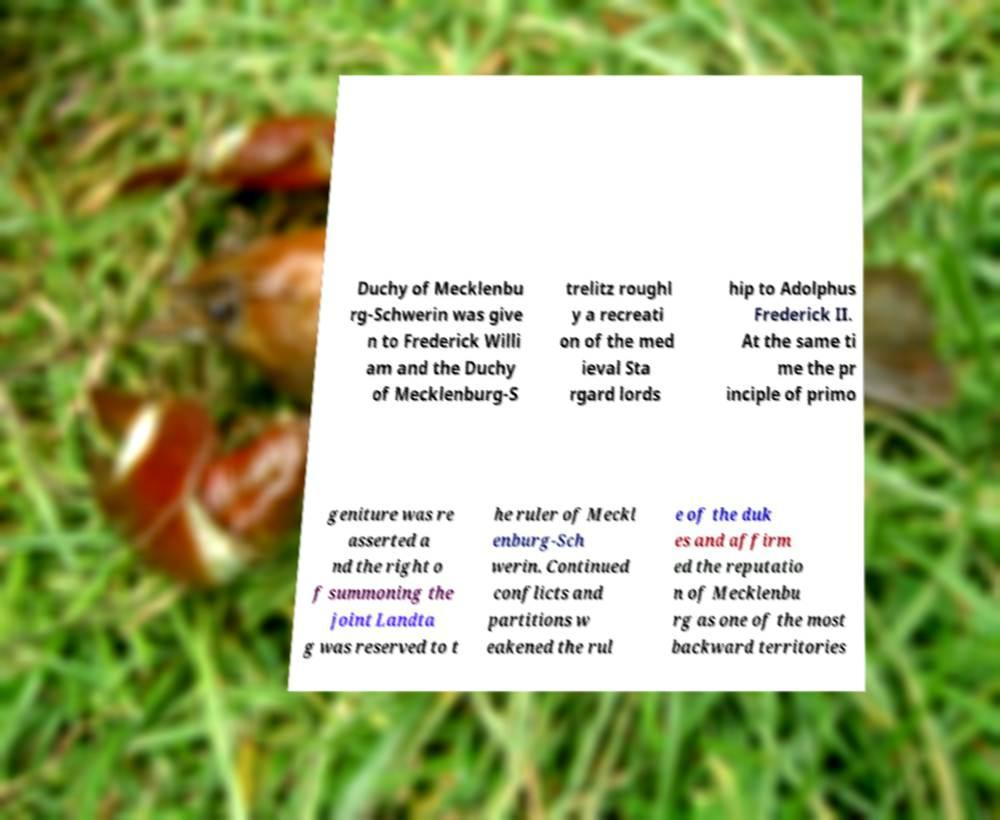Can you read and provide the text displayed in the image?This photo seems to have some interesting text. Can you extract and type it out for me? Duchy of Mecklenbu rg-Schwerin was give n to Frederick Willi am and the Duchy of Mecklenburg-S trelitz roughl y a recreati on of the med ieval Sta rgard lords hip to Adolphus Frederick II. At the same ti me the pr inciple of primo geniture was re asserted a nd the right o f summoning the joint Landta g was reserved to t he ruler of Meckl enburg-Sch werin. Continued conflicts and partitions w eakened the rul e of the duk es and affirm ed the reputatio n of Mecklenbu rg as one of the most backward territories 